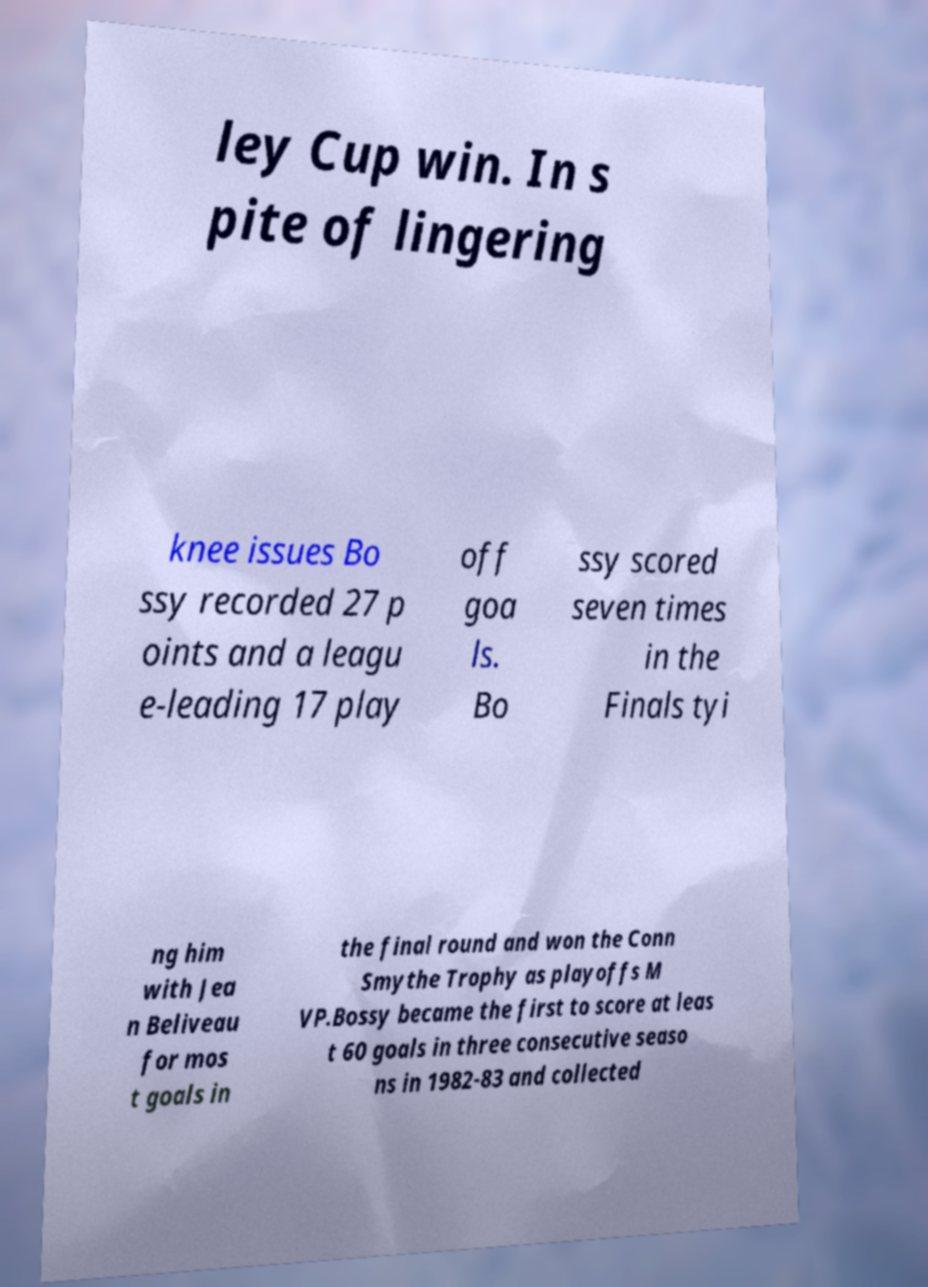Can you accurately transcribe the text from the provided image for me? ley Cup win. In s pite of lingering knee issues Bo ssy recorded 27 p oints and a leagu e-leading 17 play off goa ls. Bo ssy scored seven times in the Finals tyi ng him with Jea n Beliveau for mos t goals in the final round and won the Conn Smythe Trophy as playoffs M VP.Bossy became the first to score at leas t 60 goals in three consecutive seaso ns in 1982-83 and collected 